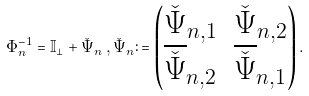<formula> <loc_0><loc_0><loc_500><loc_500>\Phi _ { n } ^ { - 1 } = { \mathbb { I } } _ { \bot } + \check { \Psi } _ { n } \, , \check { \Psi } _ { n } \colon = \begin{pmatrix} \check { \Psi } _ { n , 1 } & \check { \Psi } _ { n , 2 } \\ \overline { \check { \Psi } } _ { n , 2 } & \overline { \check { \Psi } } _ { n , 1 } \end{pmatrix} .</formula> 